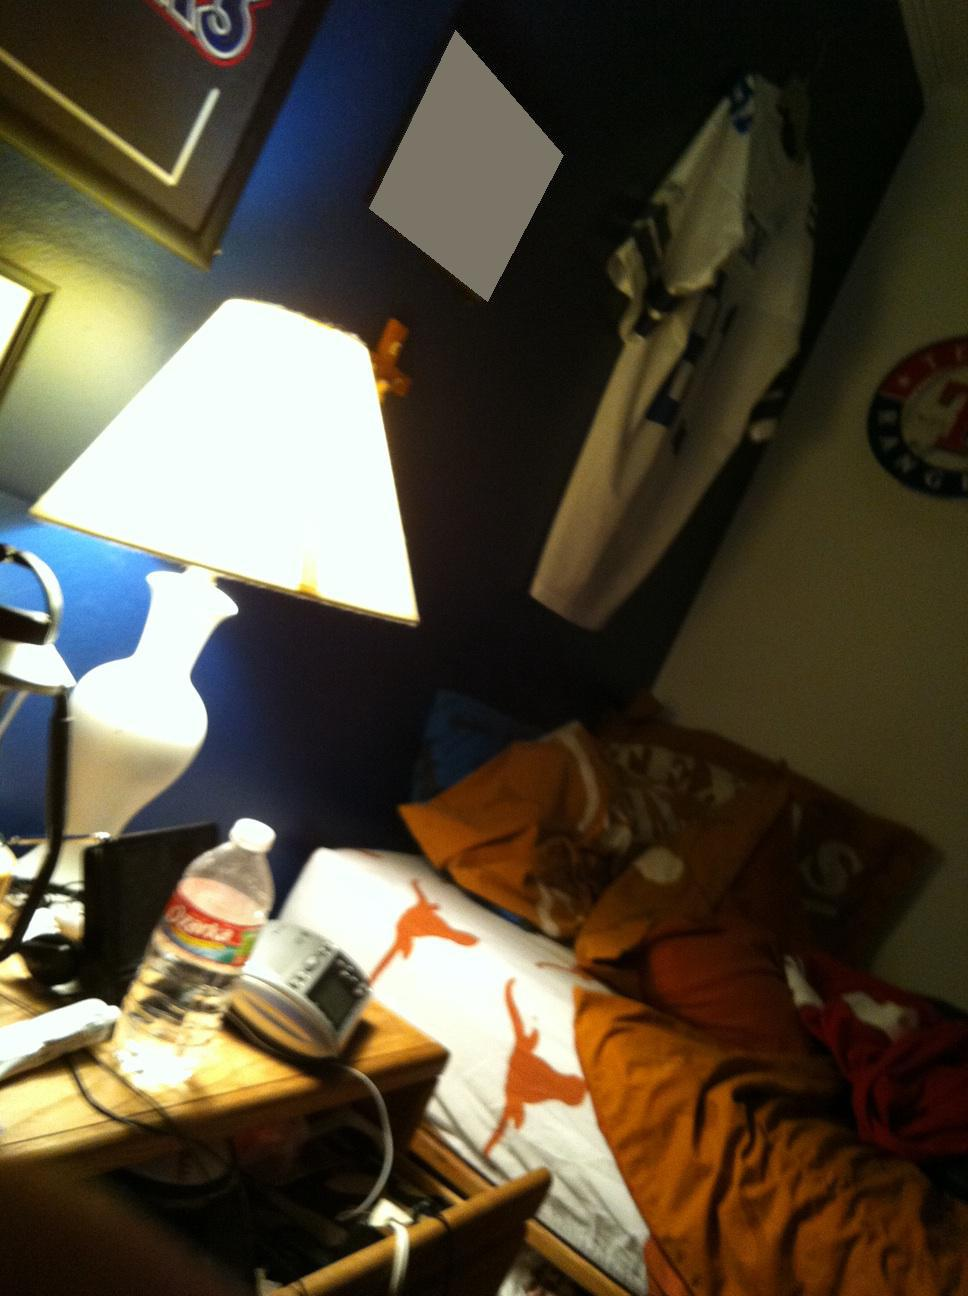Is my light off? No, the light is not off. The lamp in the image is clearly illuminated, shedding light on the surrounding area. 